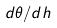Convert formula to latex. <formula><loc_0><loc_0><loc_500><loc_500>d \theta / d h</formula> 